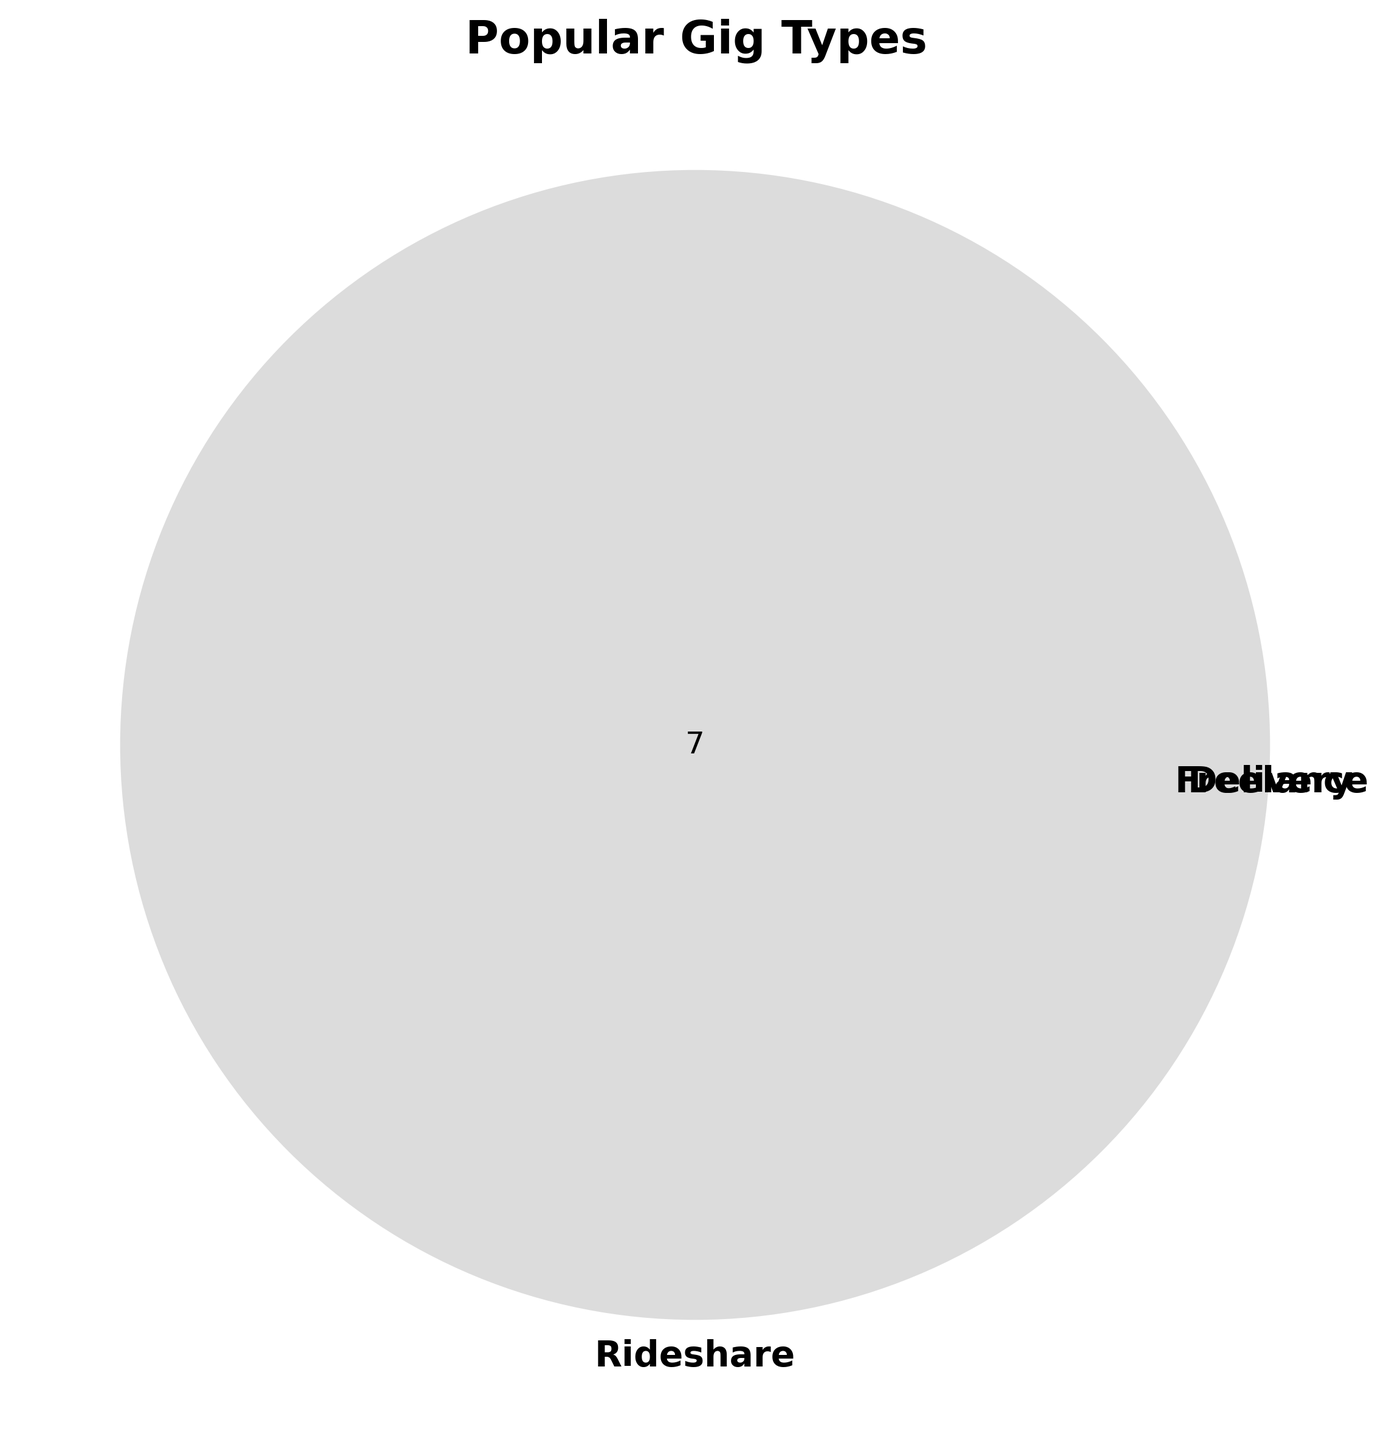What is the title of the figure? The title is displayed at the top of the figure and is labeled as 'Popular Gig Types'.
Answer: Popular Gig Types Which gig type category has the most unique items? By looking at the Venn diagram, we can see that the Delivery category has all its items unique and no intersections, indicating the most number of unique items.
Answer: Delivery Are there any items that fall into multiple gig type categories? The Venn diagram shows no intersections between the categories, indicating no items falling into multiple categories.
Answer: No How many items belong to the Delivery category? Counting the items in the Delivery circle within the Venn diagram, we find there are 7 items: DoorDash, Instacart, Grubhub, Postmates, Uber Eats, Amazon Flex, and Deliveroo.
Answer: 7 Do any categories overlap with Freelance? Checking the intersections of the Venn diagram, the Freelance circle does not overlap with any other categories.
Answer: No Which gig type has no items? From the Venn diagram, it is evident that the Rideshare and Freelance categories have no items listed within them.
Answer: Rideshare, Freelance Which category is represented in the lightest color? Observing the Venn diagram, the Freelance circle is shown in the lightest color among the three categories.
Answer: Freelance How many gig types are represented in the figure? The title of the figure and the labels of the Venn diagram sections indicate three types: Rideshare, Delivery, and Freelance.
Answer: 3 What is the color of the Delivery section in the Venn diagram? The color of the circles in the Venn diagram indicates the Delivery section is represented in a light grey color.
Answer: Light grey 